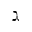<formula> <loc_0><loc_0><loc_500><loc_500>\gimel</formula> 